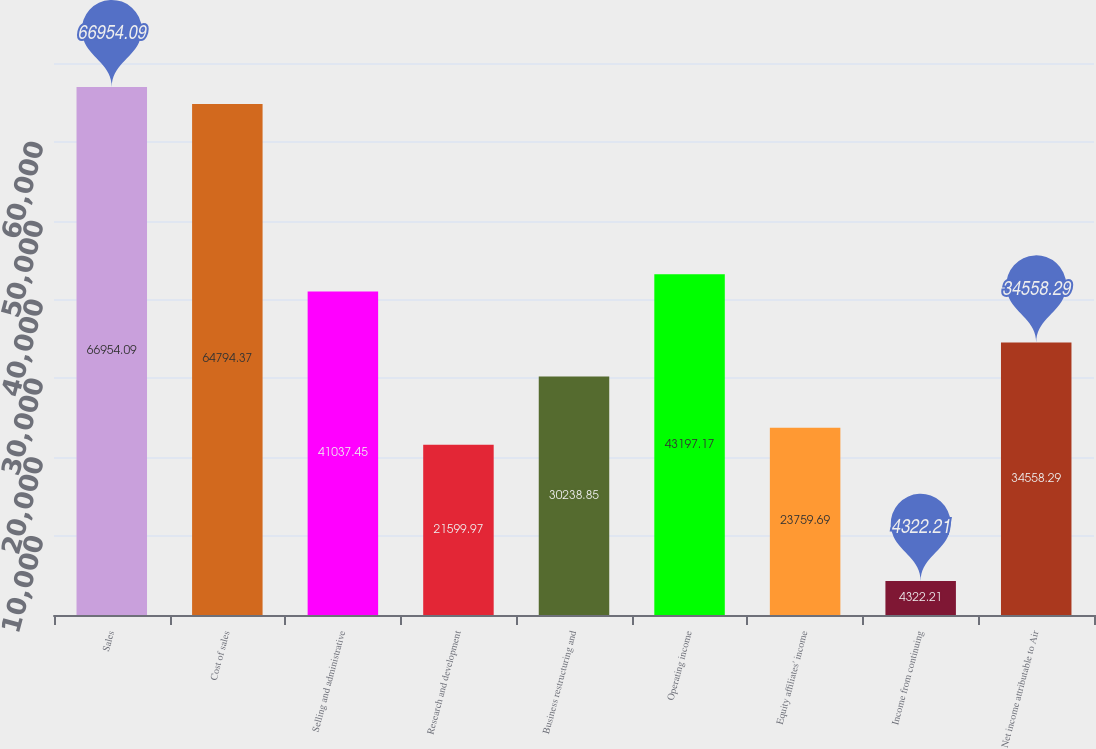Convert chart. <chart><loc_0><loc_0><loc_500><loc_500><bar_chart><fcel>Sales<fcel>Cost of sales<fcel>Selling and administrative<fcel>Research and development<fcel>Business restructuring and<fcel>Operating income<fcel>Equity affiliates' income<fcel>Income from continuing<fcel>Net income attributable to Air<nl><fcel>66954.1<fcel>64794.4<fcel>41037.4<fcel>21600<fcel>30238.8<fcel>43197.2<fcel>23759.7<fcel>4322.21<fcel>34558.3<nl></chart> 